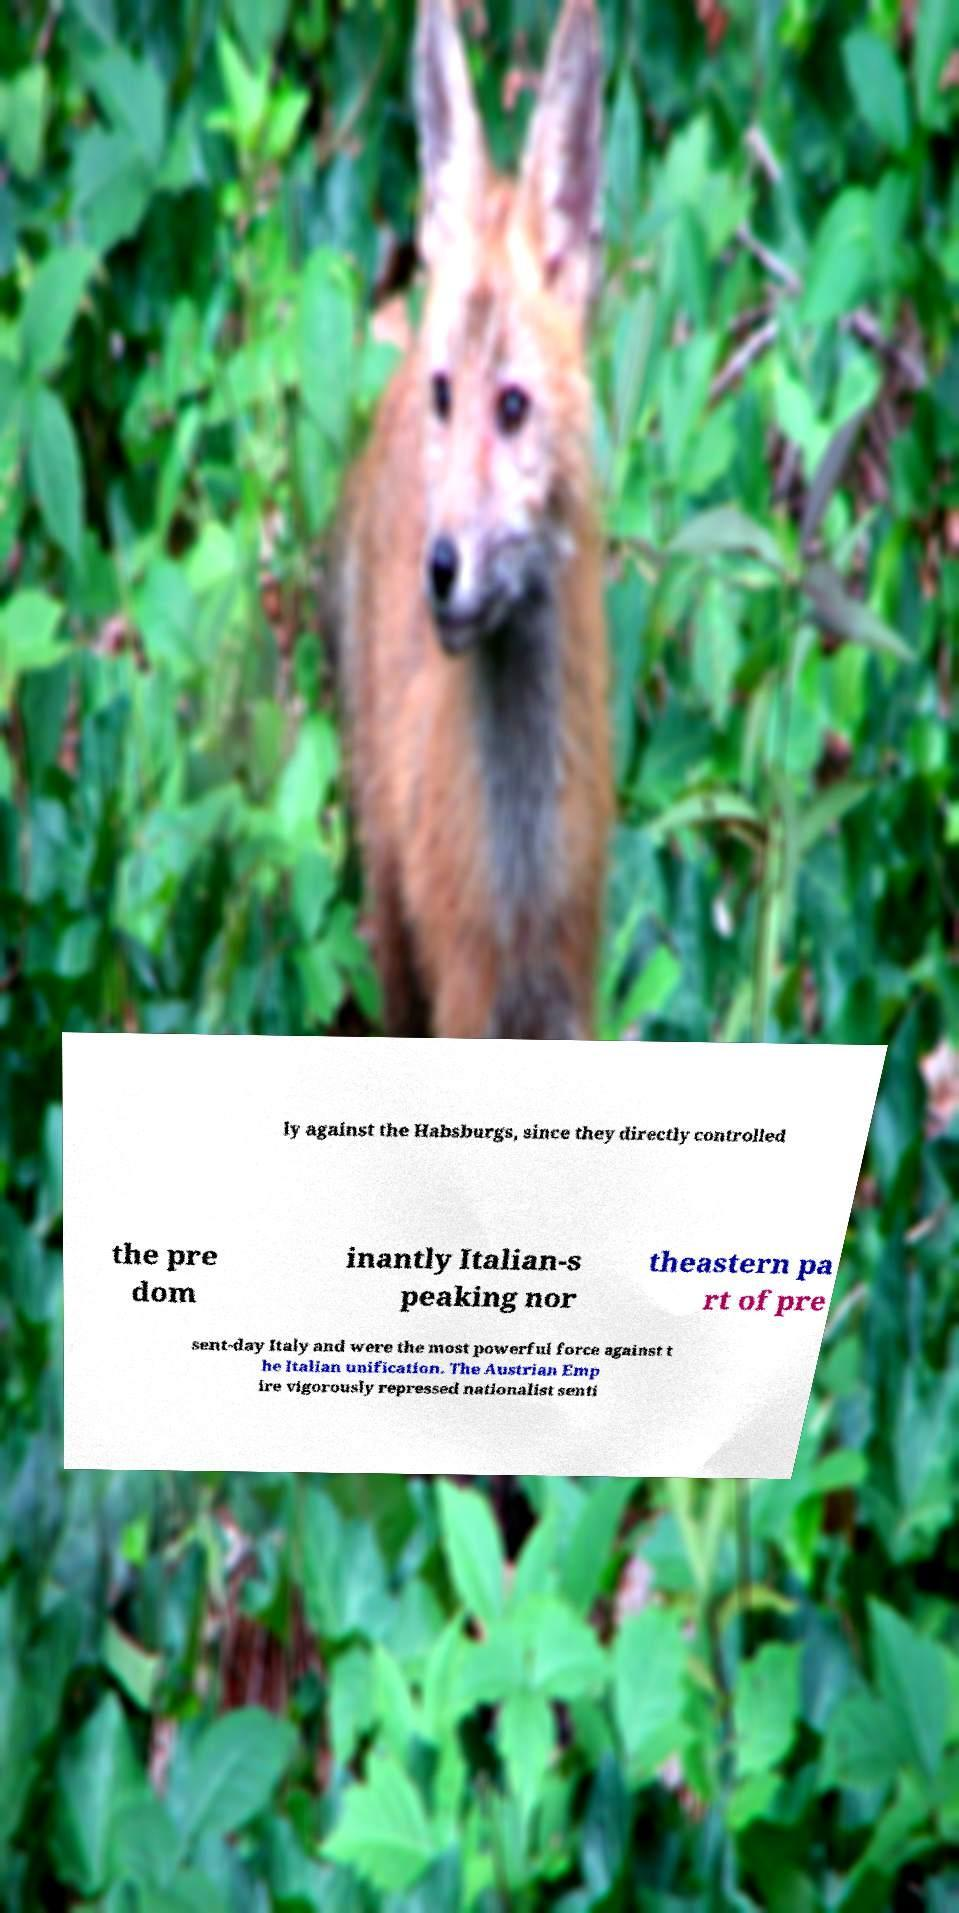Could you extract and type out the text from this image? ly against the Habsburgs, since they directly controlled the pre dom inantly Italian-s peaking nor theastern pa rt of pre sent-day Italy and were the most powerful force against t he Italian unification. The Austrian Emp ire vigorously repressed nationalist senti 